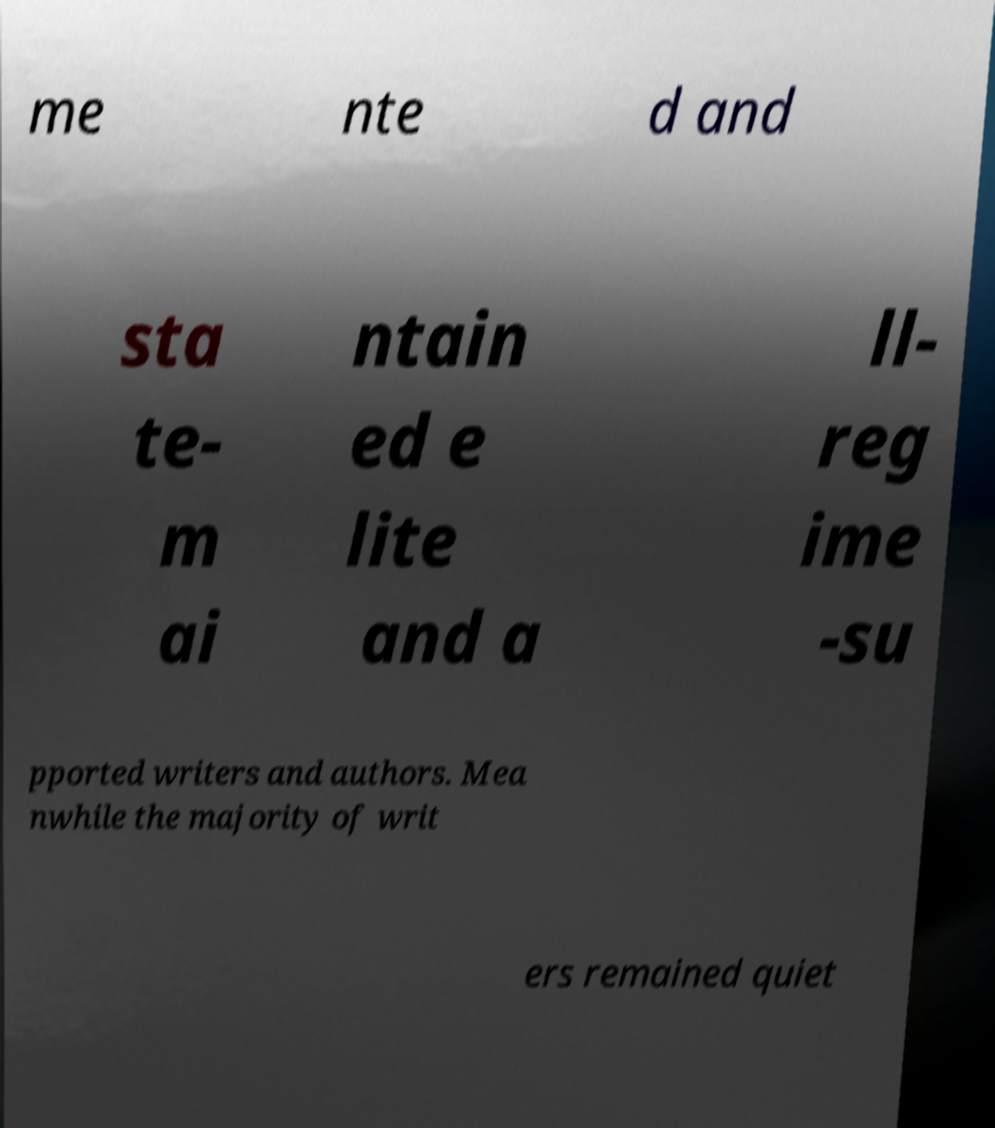Could you assist in decoding the text presented in this image and type it out clearly? me nte d and sta te- m ai ntain ed e lite and a ll- reg ime -su pported writers and authors. Mea nwhile the majority of writ ers remained quiet 